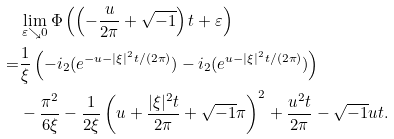<formula> <loc_0><loc_0><loc_500><loc_500>& \lim _ { \varepsilon \searrow 0 } \Phi \left ( \left ( - \frac { u } { 2 \pi } + \sqrt { - 1 } \right ) t + \varepsilon \right ) \\ = & \frac { 1 } { \xi } \left ( - \L i _ { 2 } ( e ^ { - u - | \xi | ^ { 2 } t / ( 2 \pi ) } ) - \L i _ { 2 } ( e ^ { u - | \xi | ^ { 2 } t / ( 2 \pi ) } ) \right ) \\ & - \frac { \pi ^ { 2 } } { 6 \xi } - \frac { 1 } { 2 \xi } \left ( u + \frac { | \xi | ^ { 2 } t } { 2 \pi } + \sqrt { - 1 } \pi \right ) ^ { 2 } + \frac { u ^ { 2 } t } { 2 \pi } - \sqrt { - 1 } u t .</formula> 